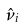Convert formula to latex. <formula><loc_0><loc_0><loc_500><loc_500>\hat { \nu } _ { i }</formula> 